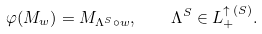<formula> <loc_0><loc_0><loc_500><loc_500>\varphi ( M _ { w } ) = M _ { \Lambda ^ { S } \circ w } , \quad \Lambda ^ { S } \in L _ { + } ^ { \uparrow \, ( S ) } .</formula> 